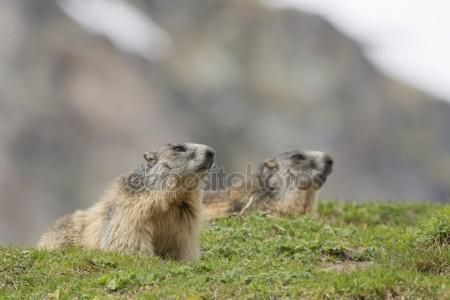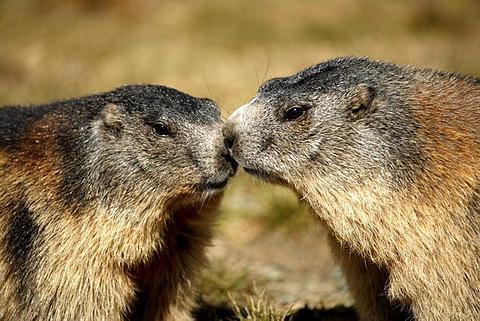The first image is the image on the left, the second image is the image on the right. Examine the images to the left and right. Is the description "Marmots are standing on hind legs facing each other" accurate? Answer yes or no. No. 